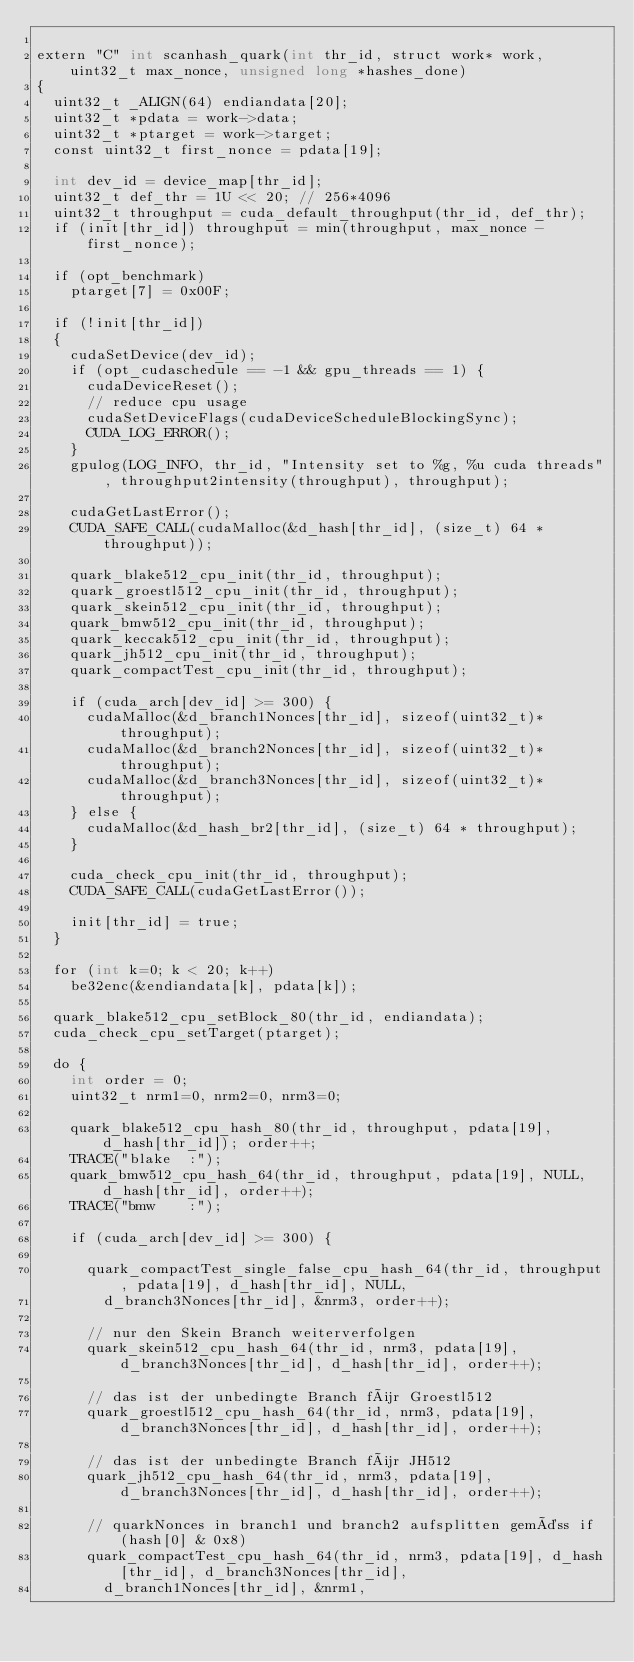<code> <loc_0><loc_0><loc_500><loc_500><_Cuda_>
extern "C" int scanhash_quark(int thr_id, struct work* work, uint32_t max_nonce, unsigned long *hashes_done)
{
	uint32_t _ALIGN(64) endiandata[20];
	uint32_t *pdata = work->data;
	uint32_t *ptarget = work->target;
	const uint32_t first_nonce = pdata[19];

	int dev_id = device_map[thr_id];
	uint32_t def_thr = 1U << 20; // 256*4096
	uint32_t throughput = cuda_default_throughput(thr_id, def_thr);
	if (init[thr_id]) throughput = min(throughput, max_nonce - first_nonce);

	if (opt_benchmark)
		ptarget[7] = 0x00F;

	if (!init[thr_id])
	{
		cudaSetDevice(dev_id);
		if (opt_cudaschedule == -1 && gpu_threads == 1) {
			cudaDeviceReset();
			// reduce cpu usage
			cudaSetDeviceFlags(cudaDeviceScheduleBlockingSync);
			CUDA_LOG_ERROR();
		}
		gpulog(LOG_INFO, thr_id, "Intensity set to %g, %u cuda threads", throughput2intensity(throughput), throughput);

		cudaGetLastError();
		CUDA_SAFE_CALL(cudaMalloc(&d_hash[thr_id], (size_t) 64 * throughput));

		quark_blake512_cpu_init(thr_id, throughput);
		quark_groestl512_cpu_init(thr_id, throughput);
		quark_skein512_cpu_init(thr_id, throughput);
		quark_bmw512_cpu_init(thr_id, throughput);
		quark_keccak512_cpu_init(thr_id, throughput);
		quark_jh512_cpu_init(thr_id, throughput);
		quark_compactTest_cpu_init(thr_id, throughput);

		if (cuda_arch[dev_id] >= 300) {
			cudaMalloc(&d_branch1Nonces[thr_id], sizeof(uint32_t)*throughput);
			cudaMalloc(&d_branch2Nonces[thr_id], sizeof(uint32_t)*throughput);
			cudaMalloc(&d_branch3Nonces[thr_id], sizeof(uint32_t)*throughput);
		} else {
			cudaMalloc(&d_hash_br2[thr_id], (size_t) 64 * throughput);
		}

		cuda_check_cpu_init(thr_id, throughput);
		CUDA_SAFE_CALL(cudaGetLastError());

		init[thr_id] = true;
	}

	for (int k=0; k < 20; k++)
		be32enc(&endiandata[k], pdata[k]);

	quark_blake512_cpu_setBlock_80(thr_id, endiandata);
	cuda_check_cpu_setTarget(ptarget);

	do {
		int order = 0;
		uint32_t nrm1=0, nrm2=0, nrm3=0;

		quark_blake512_cpu_hash_80(thr_id, throughput, pdata[19], d_hash[thr_id]); order++;
		TRACE("blake  :");
		quark_bmw512_cpu_hash_64(thr_id, throughput, pdata[19], NULL, d_hash[thr_id], order++);
		TRACE("bmw    :");

		if (cuda_arch[dev_id] >= 300) {

			quark_compactTest_single_false_cpu_hash_64(thr_id, throughput, pdata[19], d_hash[thr_id], NULL,
				d_branch3Nonces[thr_id], &nrm3, order++);

			// nur den Skein Branch weiterverfolgen
			quark_skein512_cpu_hash_64(thr_id, nrm3, pdata[19], d_branch3Nonces[thr_id], d_hash[thr_id], order++);

			// das ist der unbedingte Branch für Groestl512
			quark_groestl512_cpu_hash_64(thr_id, nrm3, pdata[19], d_branch3Nonces[thr_id], d_hash[thr_id], order++);

			// das ist der unbedingte Branch für JH512
			quark_jh512_cpu_hash_64(thr_id, nrm3, pdata[19], d_branch3Nonces[thr_id], d_hash[thr_id], order++);

			// quarkNonces in branch1 und branch2 aufsplitten gemäss if (hash[0] & 0x8)
			quark_compactTest_cpu_hash_64(thr_id, nrm3, pdata[19], d_hash[thr_id], d_branch3Nonces[thr_id],
				d_branch1Nonces[thr_id], &nrm1,</code> 